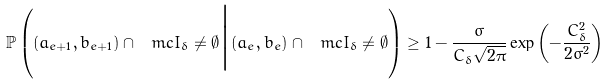Convert formula to latex. <formula><loc_0><loc_0><loc_500><loc_500>\mathbb { P } \left ( ( a _ { e + 1 } , b _ { e + 1 } ) \cap \ m c { I } _ { \delta } \neq \emptyset \Big | ( a _ { e } , b _ { e } ) \cap \ m c { I } _ { \delta } \neq \emptyset \right ) \geq 1 - \frac { \sigma } { C _ { \delta } \sqrt { 2 \pi } } \exp \left ( - \frac { C _ { \delta } ^ { 2 } } { 2 \sigma ^ { 2 } } \right )</formula> 